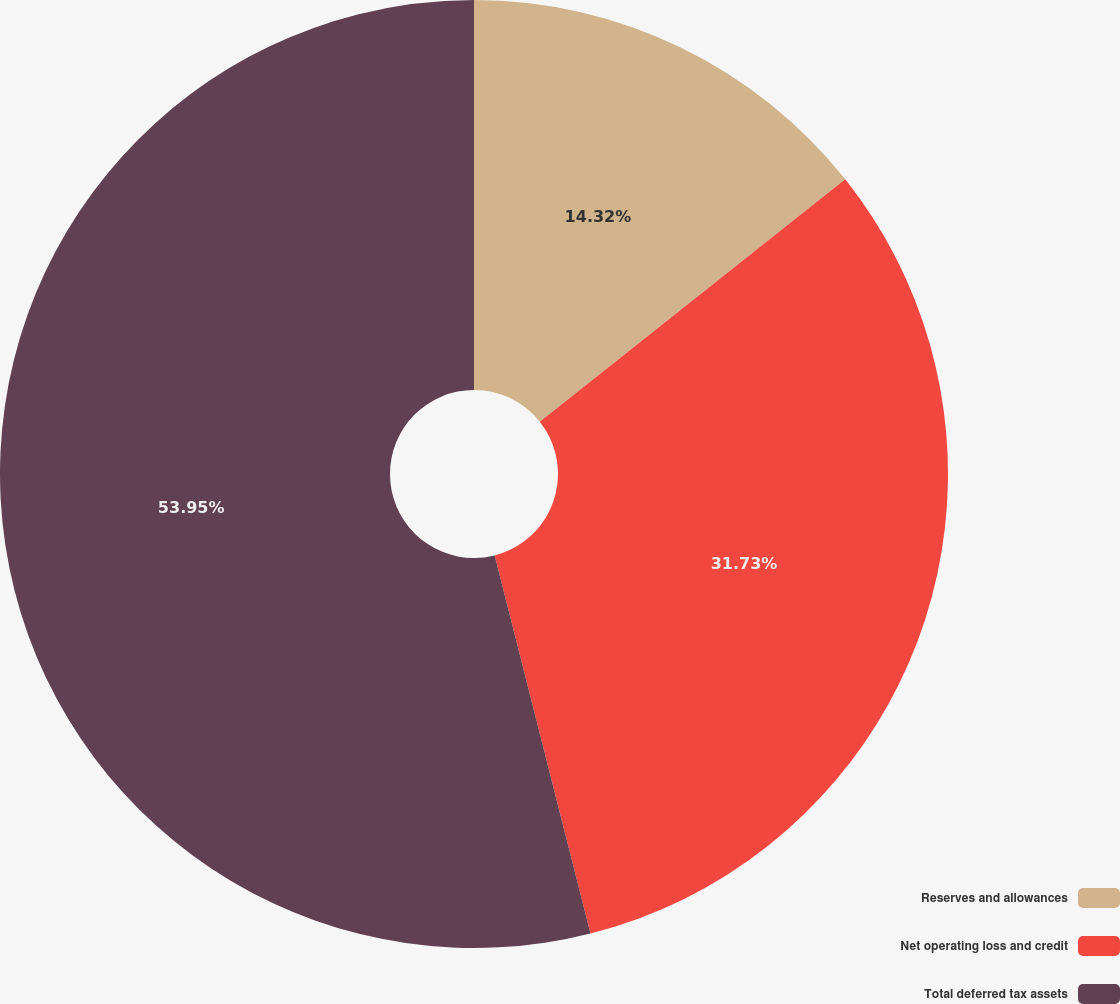Convert chart to OTSL. <chart><loc_0><loc_0><loc_500><loc_500><pie_chart><fcel>Reserves and allowances<fcel>Net operating loss and credit<fcel>Total deferred tax assets<nl><fcel>14.32%<fcel>31.73%<fcel>53.95%<nl></chart> 